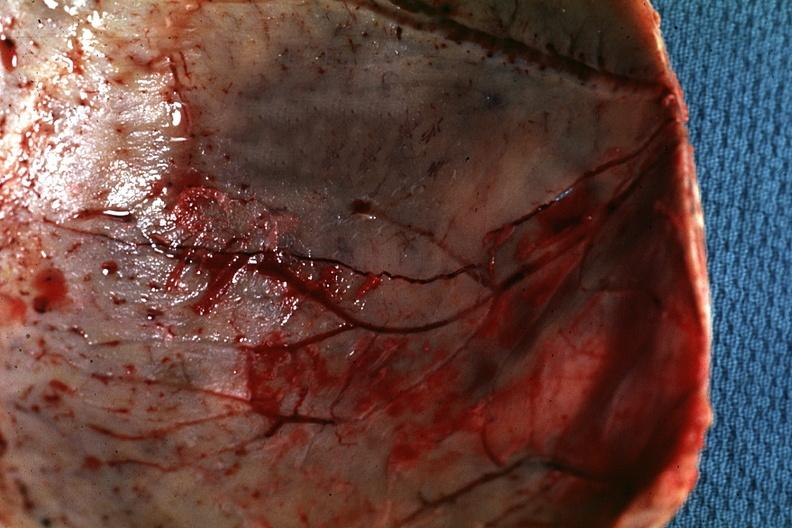what is fracture line shown?
Answer the question using a single word or phrase. Very thin skull eggshell type 